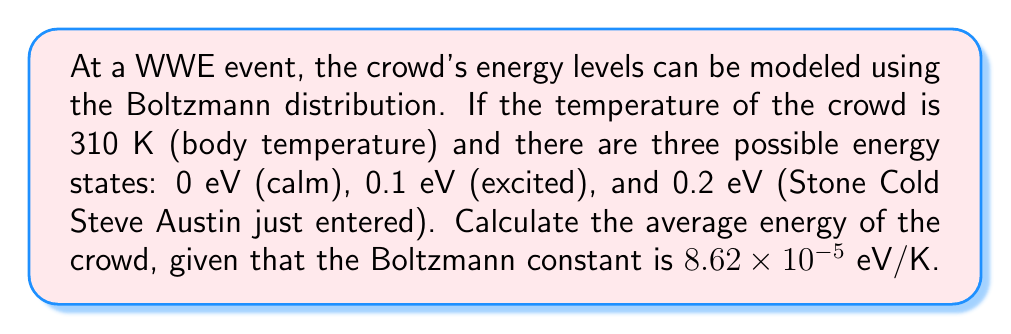Help me with this question. Let's approach this step-by-step:

1) The Boltzmann distribution gives the probability of a system being in a state with energy $E_i$:

   $$P_i = \frac{e^{-E_i/kT}}{Z}$$

   where $Z$ is the partition function: $Z = \sum_i e^{-E_i/kT}$

2) First, let's calculate $kT$:
   $kT = (8.62 \times 10^{-5} \text{ eV/K})(310 \text{ K}) = 0.02672 \text{ eV}$

3) Now, let's calculate the partition function $Z$:
   $$Z = e^{-0/0.02672} + e^{-0.1/0.02672} + e^{-0.2/0.02672} = 1 + 0.0246 + 0.0006 = 1.0252$$

4) The probabilities for each state are:
   $$P_0 = \frac{1}{1.0252} = 0.9754$$
   $$P_{0.1} = \frac{0.0246}{1.0252} = 0.0240$$
   $$P_{0.2} = \frac{0.0006}{1.0252} = 0.0006$$

5) The average energy is given by:
   $$\langle E \rangle = \sum_i E_i P_i$$

6) Calculating the average energy:
   $$\langle E \rangle = (0 \times 0.9754) + (0.1 \times 0.0240) + (0.2 \times 0.0006)$$
   $$\langle E \rangle = 0 + 0.0024 + 0.00012 = 0.00252 \text{ eV}$$
Answer: 0.00252 eV 